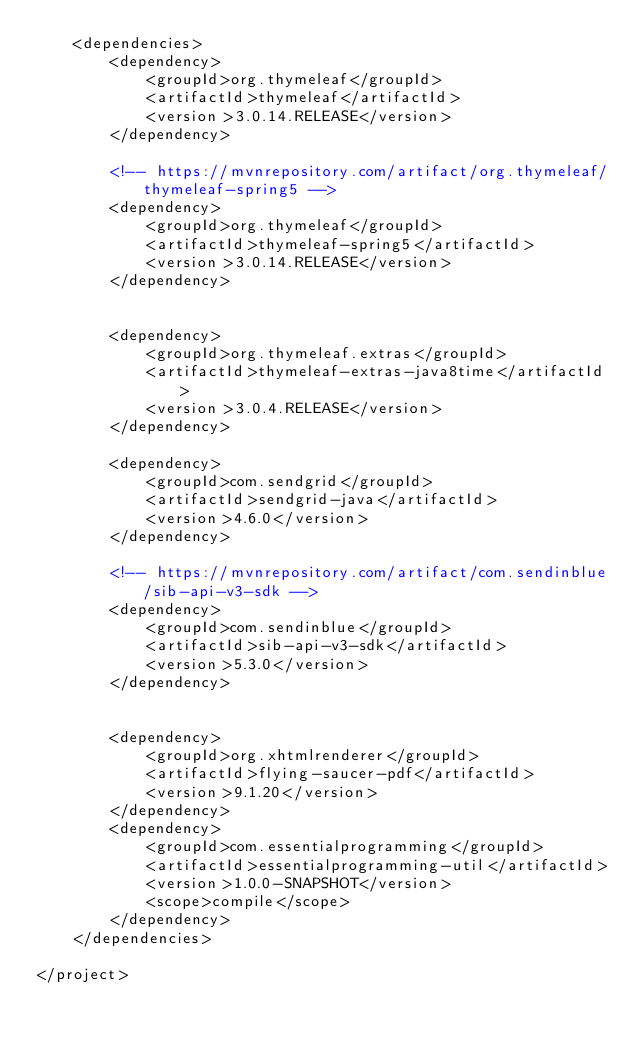Convert code to text. <code><loc_0><loc_0><loc_500><loc_500><_XML_>    <dependencies>
        <dependency>
            <groupId>org.thymeleaf</groupId>
            <artifactId>thymeleaf</artifactId>
            <version>3.0.14.RELEASE</version>
        </dependency>

        <!-- https://mvnrepository.com/artifact/org.thymeleaf/thymeleaf-spring5 -->
        <dependency>
            <groupId>org.thymeleaf</groupId>
            <artifactId>thymeleaf-spring5</artifactId>
            <version>3.0.14.RELEASE</version>
        </dependency>


        <dependency>
            <groupId>org.thymeleaf.extras</groupId>
            <artifactId>thymeleaf-extras-java8time</artifactId>
            <version>3.0.4.RELEASE</version>
        </dependency>

        <dependency>
            <groupId>com.sendgrid</groupId>
            <artifactId>sendgrid-java</artifactId>
            <version>4.6.0</version>
        </dependency>

        <!-- https://mvnrepository.com/artifact/com.sendinblue/sib-api-v3-sdk -->
        <dependency>
            <groupId>com.sendinblue</groupId>
            <artifactId>sib-api-v3-sdk</artifactId>
            <version>5.3.0</version>
        </dependency>


        <dependency>
            <groupId>org.xhtmlrenderer</groupId>
            <artifactId>flying-saucer-pdf</artifactId>
            <version>9.1.20</version>
        </dependency>
        <dependency>
            <groupId>com.essentialprogramming</groupId>
            <artifactId>essentialprogramming-util</artifactId>
            <version>1.0.0-SNAPSHOT</version>
            <scope>compile</scope>
        </dependency>
    </dependencies>

</project></code> 